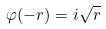<formula> <loc_0><loc_0><loc_500><loc_500>\varphi ( - r ) = i \sqrt { r }</formula> 